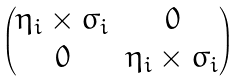Convert formula to latex. <formula><loc_0><loc_0><loc_500><loc_500>\begin{pmatrix} \eta _ { i } \times \sigma _ { i } & 0 \\ 0 & \eta _ { i } \times \sigma _ { i } \end{pmatrix}</formula> 